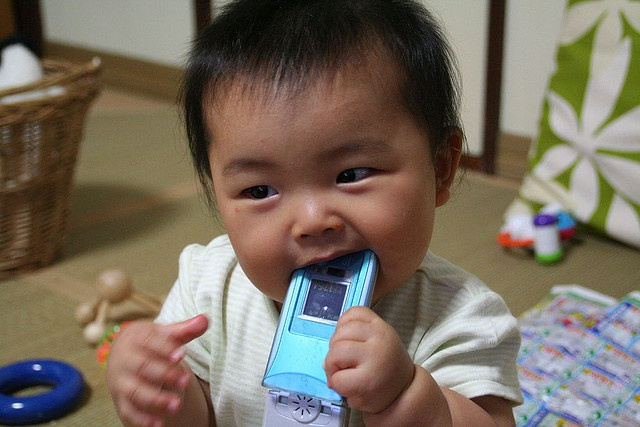Describe the objects in this image and their specific colors. I can see people in black, gray, maroon, and lightgray tones and cell phone in black, lightblue, and gray tones in this image. 